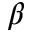Convert formula to latex. <formula><loc_0><loc_0><loc_500><loc_500>\beta</formula> 